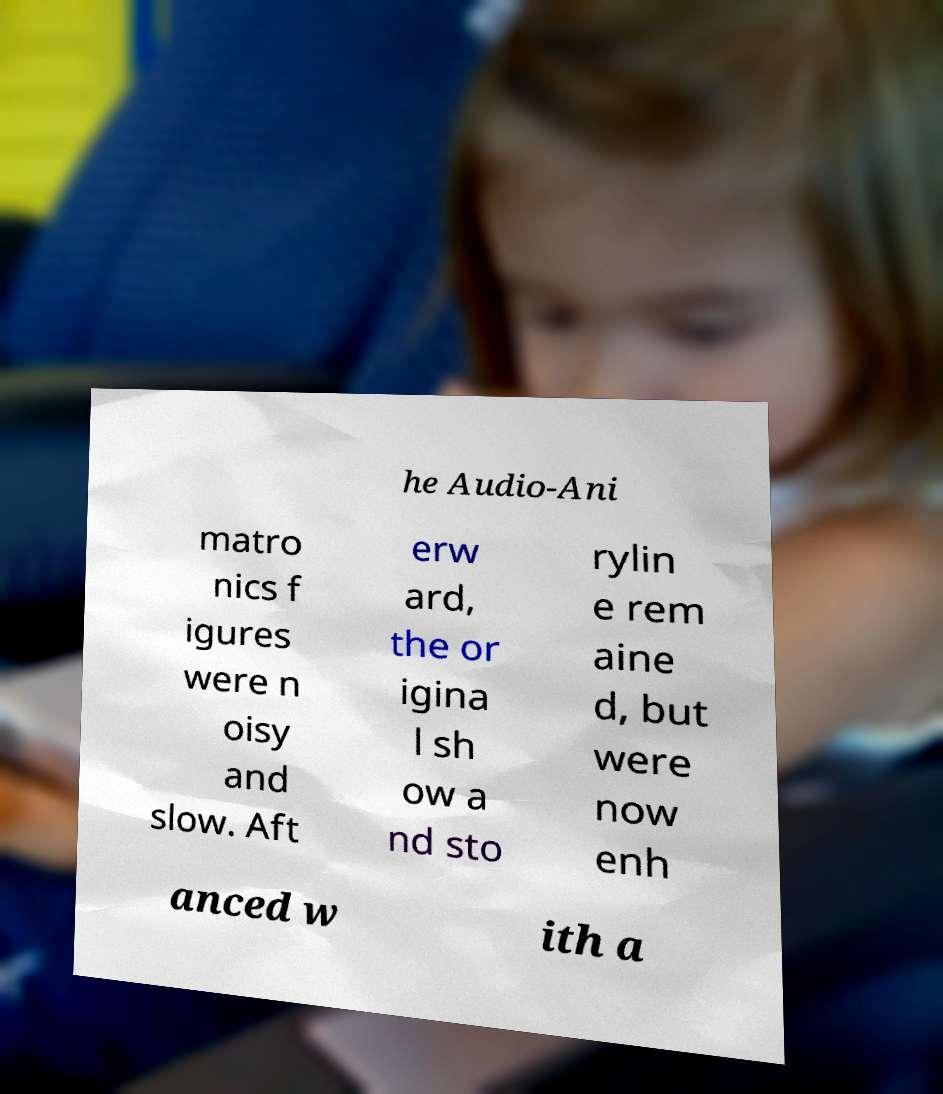For documentation purposes, I need the text within this image transcribed. Could you provide that? he Audio-Ani matro nics f igures were n oisy and slow. Aft erw ard, the or igina l sh ow a nd sto rylin e rem aine d, but were now enh anced w ith a 